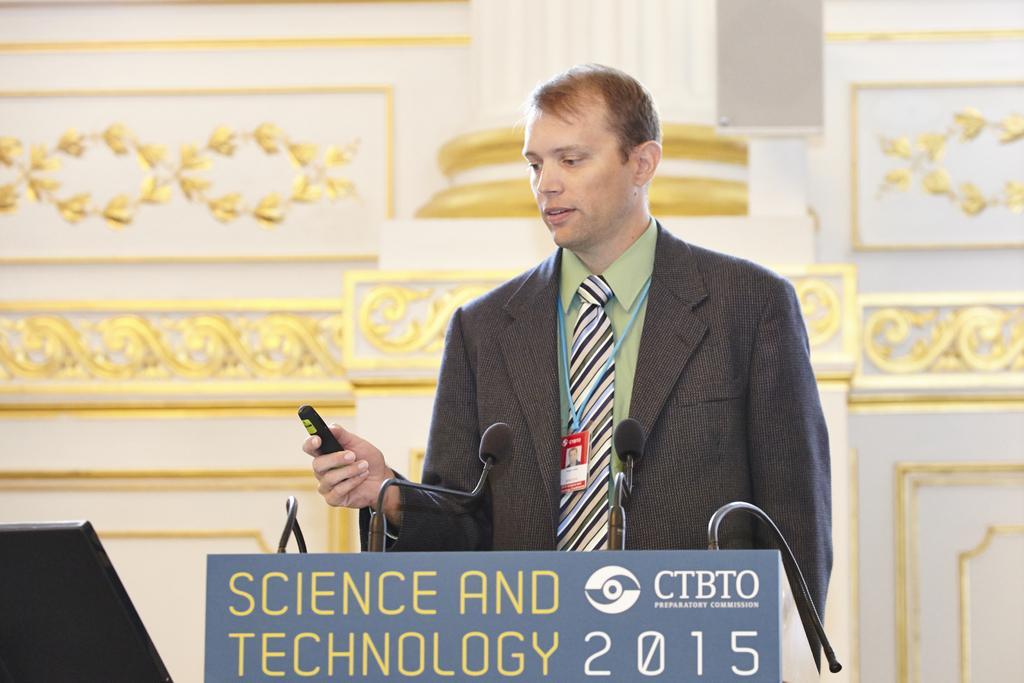Describe this image in one or two sentences. In this image we can see a person holding a remote. There is a podium with mics. In the background of the image there is wall. There is a pillar. 